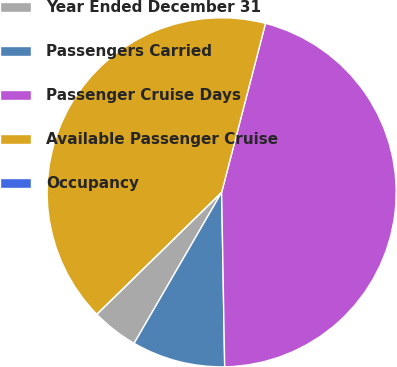Convert chart. <chart><loc_0><loc_0><loc_500><loc_500><pie_chart><fcel>Year Ended December 31<fcel>Passengers Carried<fcel>Passenger Cruise Days<fcel>Available Passenger Cruise<fcel>Occupancy<nl><fcel>4.32%<fcel>8.64%<fcel>45.68%<fcel>41.36%<fcel>0.0%<nl></chart> 